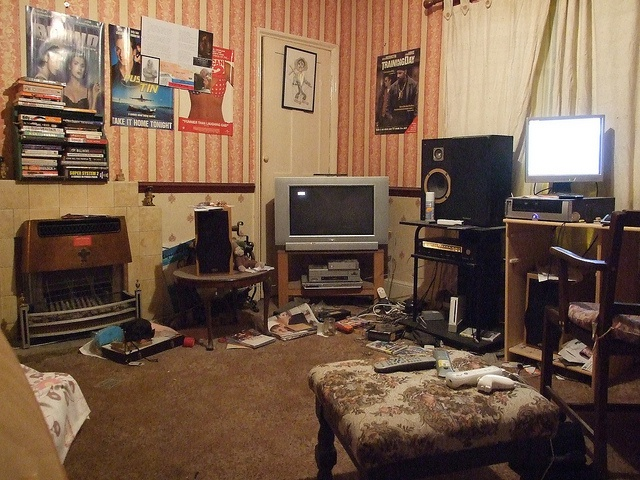Describe the objects in this image and their specific colors. I can see chair in tan, black, maroon, and gray tones, couch in tan, olive, and gray tones, tv in tan, black, and gray tones, tv in tan, white, darkgray, and gray tones, and book in tan, black, maroon, and gray tones in this image. 